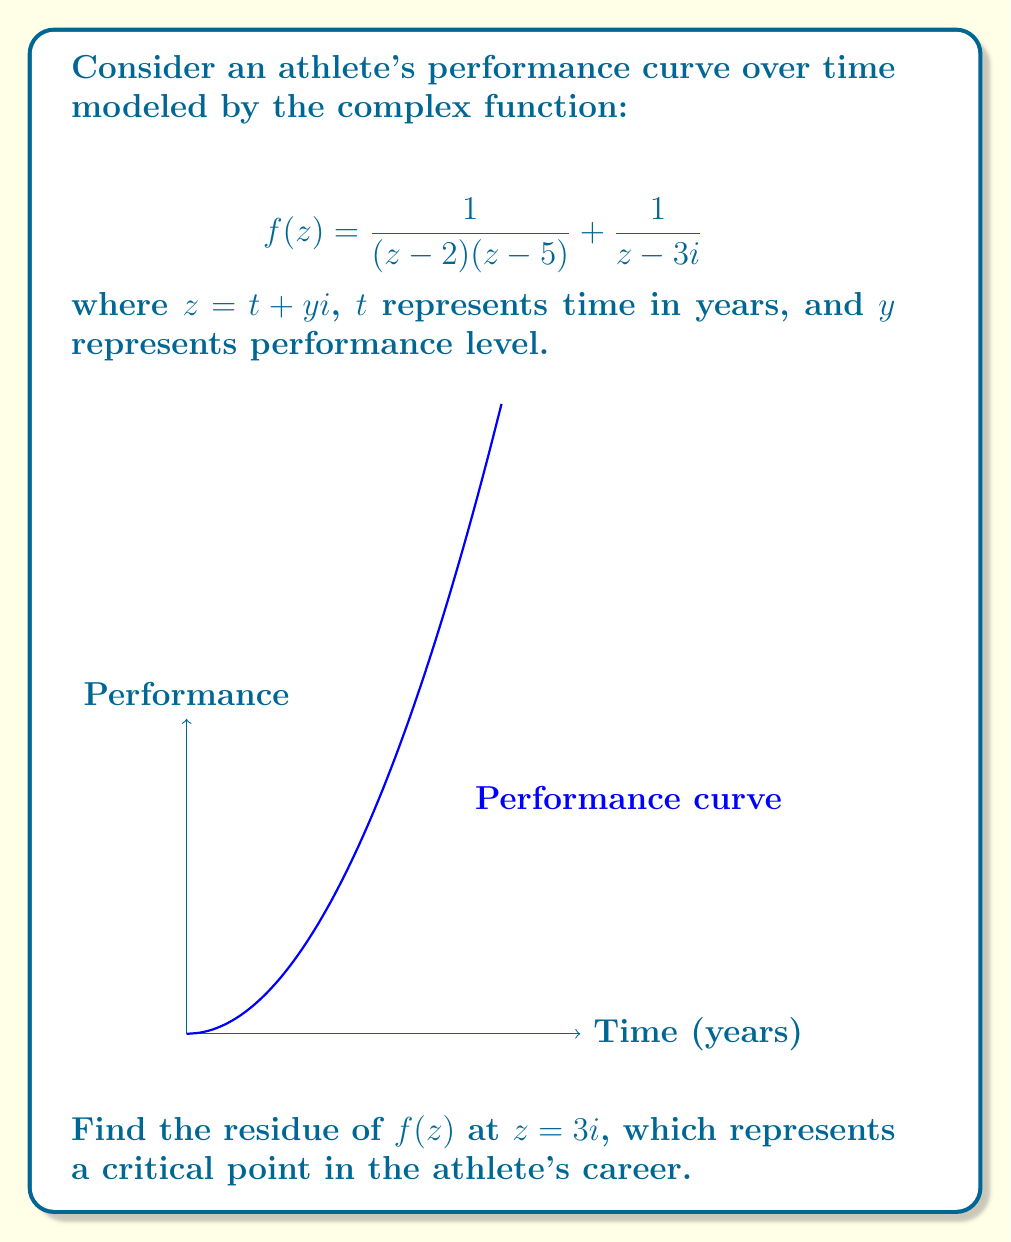Give your solution to this math problem. To find the residue of $f(z)$ at $z = 3i$, we need to follow these steps:

1) First, note that $z = 3i$ is a simple pole of $f(z)$. For a simple pole, the residue is given by:

   $$\text{Res}(f,3i) = \lim_{z \to 3i} (z-3i)f(z)$$

2) Let's substitute the function:

   $$\text{Res}(f,3i) = \lim_{z \to 3i} (z-3i)\left(\frac{1}{(z-2)(z-5)} + \frac{1}{z-3i}\right)$$

3) We can split this into two limits:

   $$\text{Res}(f,3i) = \lim_{z \to 3i} \frac{z-3i}{(z-2)(z-5)} + \lim_{z \to 3i} \frac{z-3i}{z-3i}$$

4) The second limit is straightforward:

   $$\lim_{z \to 3i} \frac{z-3i}{z-3i} = 1$$

5) For the first limit, we need to evaluate:

   $$\lim_{z \to 3i} \frac{z-3i}{(z-2)(z-5)}$$

6) Substitute $z = 3i$ directly:

   $$\frac{3i-3i}{(3i-2)(3i-5)} = \frac{0}{(-2+3i)(-5+3i)} = 0$$

7) Therefore, the residue is:

   $$\text{Res}(f,3i) = 0 + 1 = 1$$
Answer: $1$ 